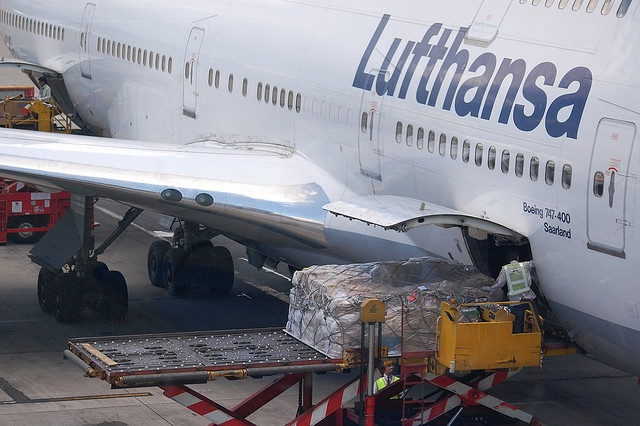Describe the objects in this image and their specific colors. I can see airplane in darkgray and lightgray tones, people in darkgray, gray, and black tones, people in darkgray, black, lightgreen, gray, and maroon tones, and people in darkgray, gray, and black tones in this image. 